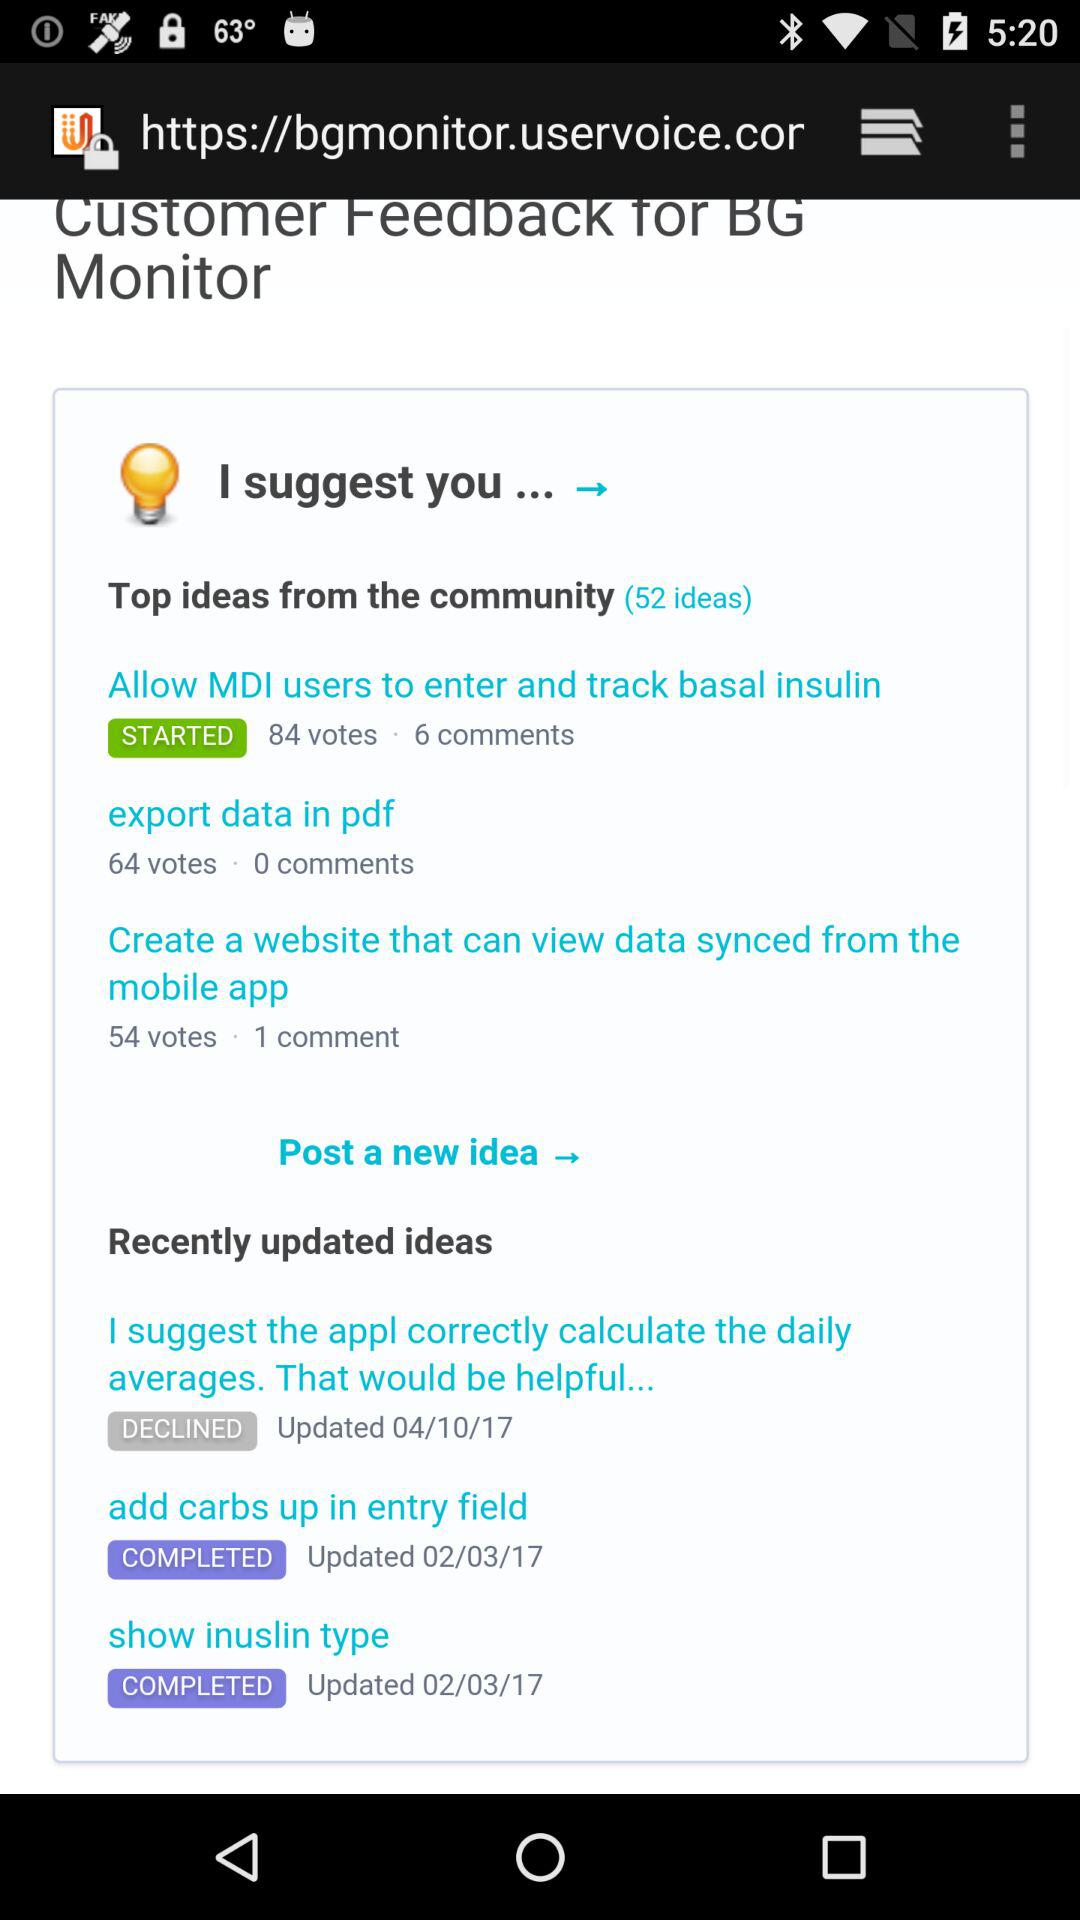How many ideas are there in the 'Recently updated ideas' section?
Answer the question using a single word or phrase. 3 